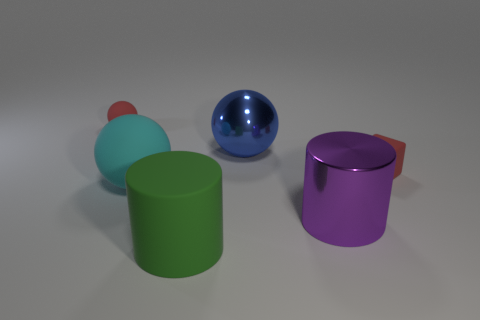What color is the small matte object on the right side of the tiny ball behind the tiny red matte thing that is to the right of the green object?
Give a very brief answer. Red. How many tiny red rubber objects are right of the blue metallic ball and to the left of the large cyan rubber thing?
Ensure brevity in your answer.  0. Is the color of the tiny matte object to the right of the rubber cylinder the same as the metallic thing behind the large purple shiny thing?
Keep it short and to the point. No. Are there any other things that are the same material as the green cylinder?
Provide a succinct answer. Yes. There is a red rubber thing that is the same shape as the big blue thing; what size is it?
Ensure brevity in your answer.  Small. There is a big metallic sphere; are there any big purple objects on the left side of it?
Your answer should be very brief. No. Are there an equal number of big green rubber things that are behind the small rubber ball and large cyan cylinders?
Keep it short and to the point. Yes. There is a red object in front of the large blue metallic ball that is on the left side of the large purple cylinder; are there any large balls that are in front of it?
Make the answer very short. Yes. What is the cyan object made of?
Offer a terse response. Rubber. How many other objects are there of the same shape as the big cyan rubber object?
Your answer should be compact. 2. 